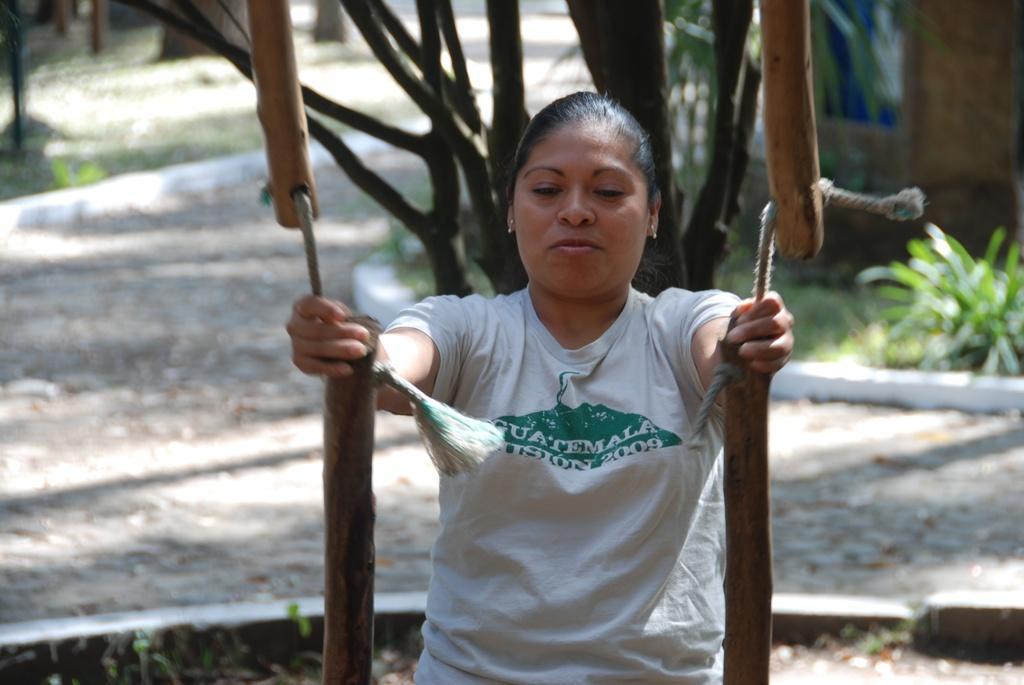In one or two sentences, can you explain what this image depicts? In this image I can see a person. The person is wearing white shirt, background I can see trees in green color. 